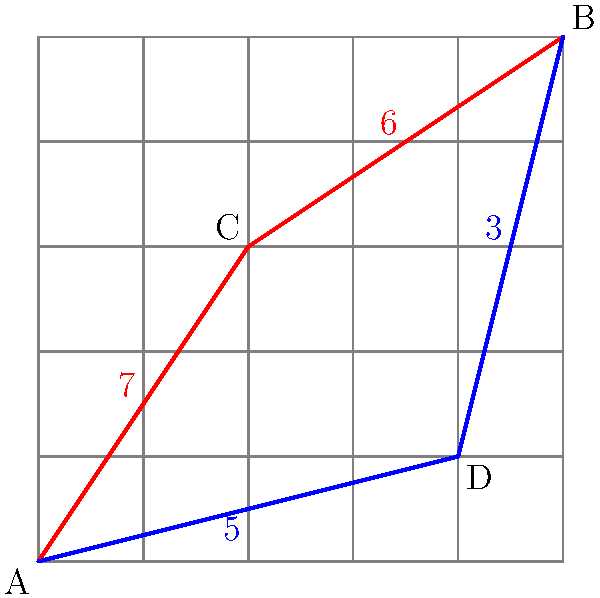As a logistic courier in a bustling city, you need to optimize your delivery route from point A to point B on the given city grid map. Two possible routes are shown: the red route passing through point C and the blue route passing through point D. The numbers on each segment represent the time (in minutes) required to travel that segment. Which route should you choose to minimize delivery time, and what is the total time saved compared to the alternative route? To solve this problem, we need to follow these steps:

1. Calculate the total time for the red route (A → C → B):
   Red route time = AC + CB = 7 + 6 = 13 minutes

2. Calculate the total time for the blue route (A → D → B):
   Blue route time = AD + DB = 5 + 3 = 8 minutes

3. Compare the two routes:
   The blue route (8 minutes) is faster than the red route (13 minutes).

4. Calculate the time saved by choosing the optimal route:
   Time saved = Red route time - Blue route time
               = 13 - 8 = 5 minutes

Therefore, as a logistic courier aiming to optimize delivery time, you should choose the blue route passing through point D. This route will save you 5 minutes compared to the alternative red route.
Answer: Blue route; 5 minutes saved 